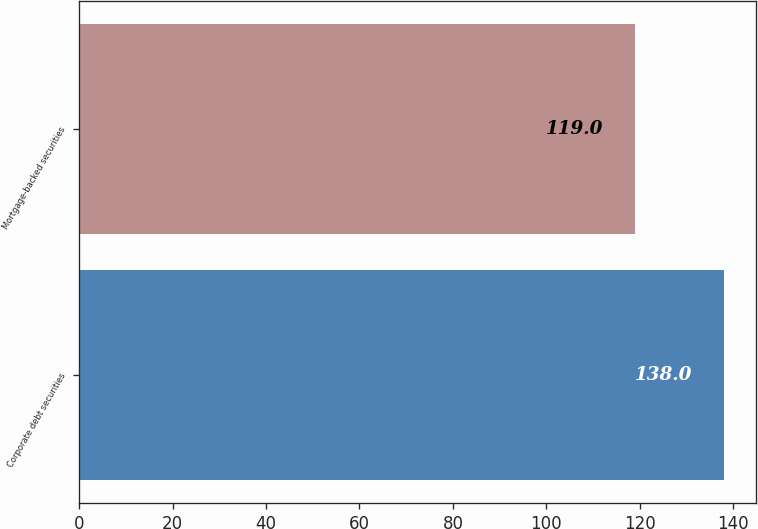Convert chart to OTSL. <chart><loc_0><loc_0><loc_500><loc_500><bar_chart><fcel>Corporate debt securities<fcel>Mortgage-backed securities<nl><fcel>138<fcel>119<nl></chart> 